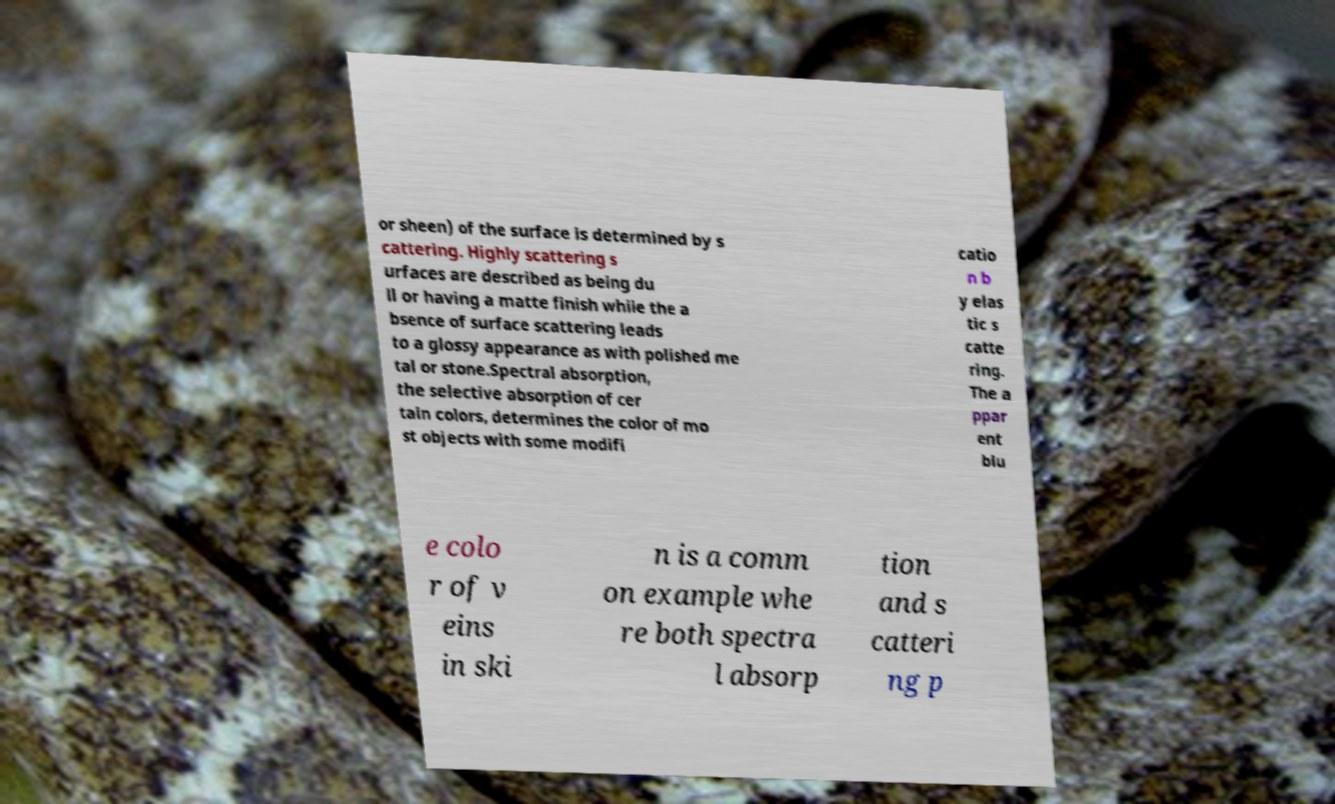Please read and relay the text visible in this image. What does it say? or sheen) of the surface is determined by s cattering. Highly scattering s urfaces are described as being du ll or having a matte finish while the a bsence of surface scattering leads to a glossy appearance as with polished me tal or stone.Spectral absorption, the selective absorption of cer tain colors, determines the color of mo st objects with some modifi catio n b y elas tic s catte ring. The a ppar ent blu e colo r of v eins in ski n is a comm on example whe re both spectra l absorp tion and s catteri ng p 